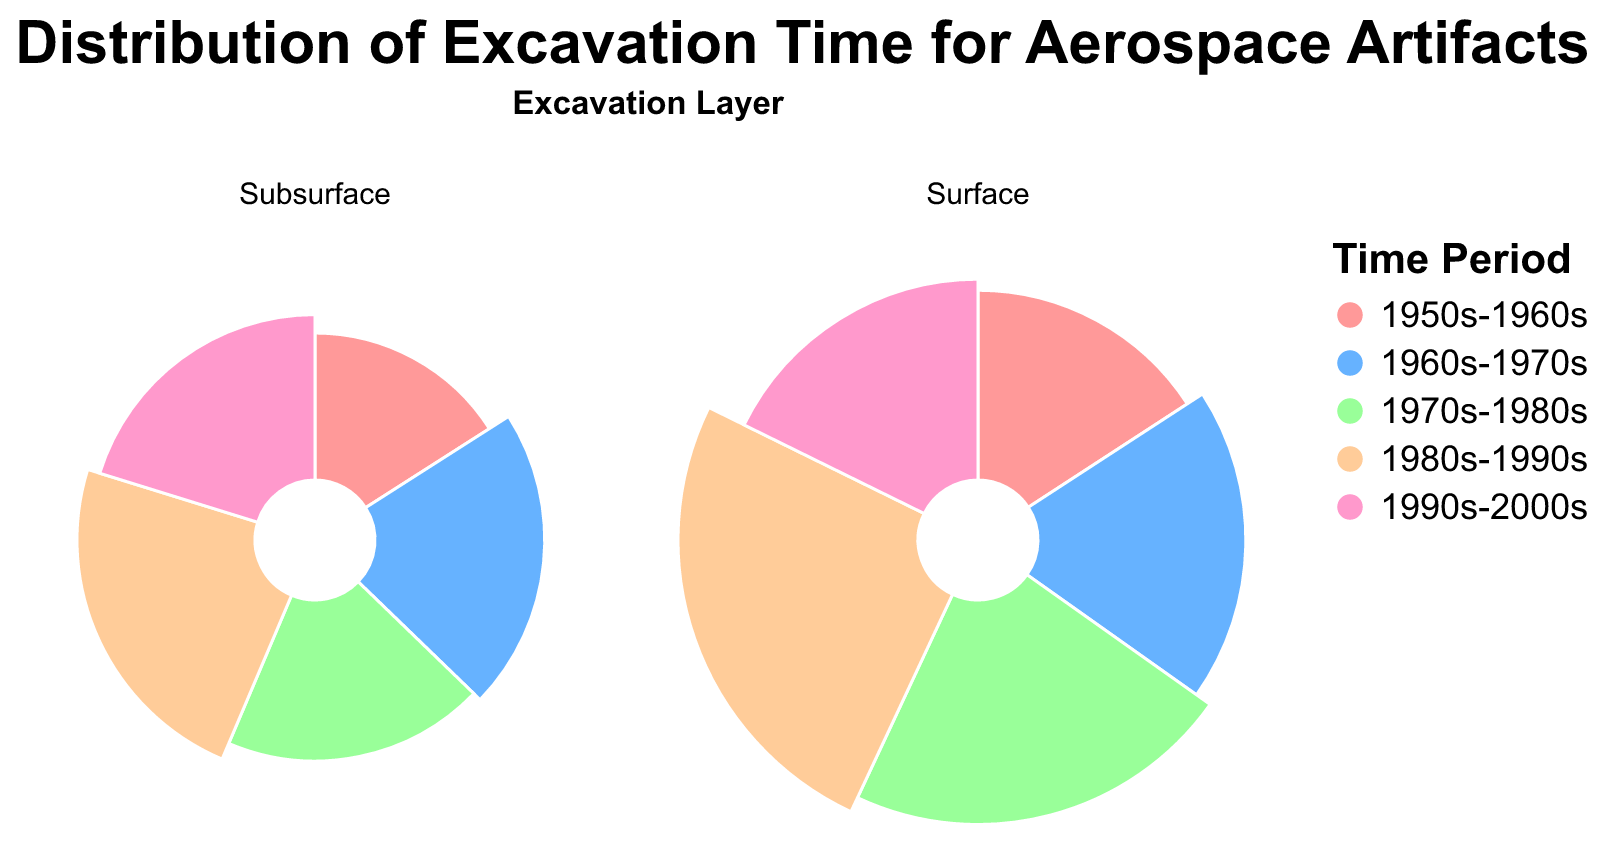Which period required the most excavation hours on the surface layer? Look at the surface layer plot and identify the slice with the largest theta value. The largest arc belongs to the "1980s-1990s" period.
Answer: 1980s-1990s Which time period layer combination had the smallest excavation hours? Identify the slice with the smallest theta value in both the surface and subsurface layers. The smallest slice appears in the "Subsurface" layer for the "1950s-1960s" period.
Answer: 1950s-1960s Subsurface How many total excavation hours were spent on subsurface artifacts from the 1970s-1980s and 1980s-1990s? Add up the excavation hours for the subsurface artifacts from these periods: Soyuz Rocket Part (18) + Hubble Telescope Component (22). Thus, 18 + 22 = 40.
Answer: 40 Which layer has the largest total excavation hours? Sum the excavation hours for both layers and compare: Surface: 25 + 30 + 35 + 40 + 28 = 158; Subsurface: 15 + 20 + 18 + 22 + 19 = 94. The Surface layer has the larger total.
Answer: Surface For the surface layer, which artifact from the 1990s-2000s has the most excavation hours? Identify the artifact from this period in the surface layer and note its excavation hours. The Mir Space Station Debris (28 hours) is the only artifact from the 1990s-2000s in this layer.
Answer: Mir Space Station Debris Which layer and time period combination has the highest excavation hours? Observe both layers and identify the combination with the largest theta value. The surface layer's 1980s-1990s period has the highest excavation hours.
Answer: Surface 1980s-1990s How do the excavation hours for subsurface artifacts from the 1960s-1970s compare to those from the 1990s-2000s? Compare the theta values of the two periods in the subsurface layer: 20 hours (1960s-1970s) vs. 19 hours (1990s-2000s). The 1960s-1970s period has 1 hour more.
Answer: 1960s-1970s have more What is the total excavation hours for both surface and subsurface layers during the 1950s-1960s period? Add the excavation hours for both layers from this period: Surface (25) + Subsurface (15) = 40.
Answer: 40 Which time period in the subsurface layer has the highest excavation hours? Observe the subsurface layer and identify the period with the largest theta value. The "1980s-1990s" period has the highest excavation hours in the subsurface layer.
Answer: 1980s-1990s By examining the surface layer, which time period had the least amount of excavation hours? Identify the slice with the smallest theta value in the surface layer. The "1950s-1960s" period has the least excavation hours in the surface layer.
Answer: 1950s-1960s 